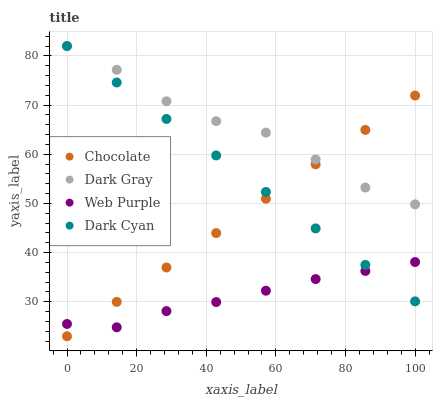Does Web Purple have the minimum area under the curve?
Answer yes or no. Yes. Does Dark Gray have the maximum area under the curve?
Answer yes or no. Yes. Does Dark Cyan have the minimum area under the curve?
Answer yes or no. No. Does Dark Cyan have the maximum area under the curve?
Answer yes or no. No. Is Dark Cyan the smoothest?
Answer yes or no. Yes. Is Dark Gray the roughest?
Answer yes or no. Yes. Is Web Purple the smoothest?
Answer yes or no. No. Is Web Purple the roughest?
Answer yes or no. No. Does Chocolate have the lowest value?
Answer yes or no. Yes. Does Dark Cyan have the lowest value?
Answer yes or no. No. Does Dark Cyan have the highest value?
Answer yes or no. Yes. Does Web Purple have the highest value?
Answer yes or no. No. Is Web Purple less than Dark Gray?
Answer yes or no. Yes. Is Dark Gray greater than Web Purple?
Answer yes or no. Yes. Does Chocolate intersect Dark Cyan?
Answer yes or no. Yes. Is Chocolate less than Dark Cyan?
Answer yes or no. No. Is Chocolate greater than Dark Cyan?
Answer yes or no. No. Does Web Purple intersect Dark Gray?
Answer yes or no. No. 